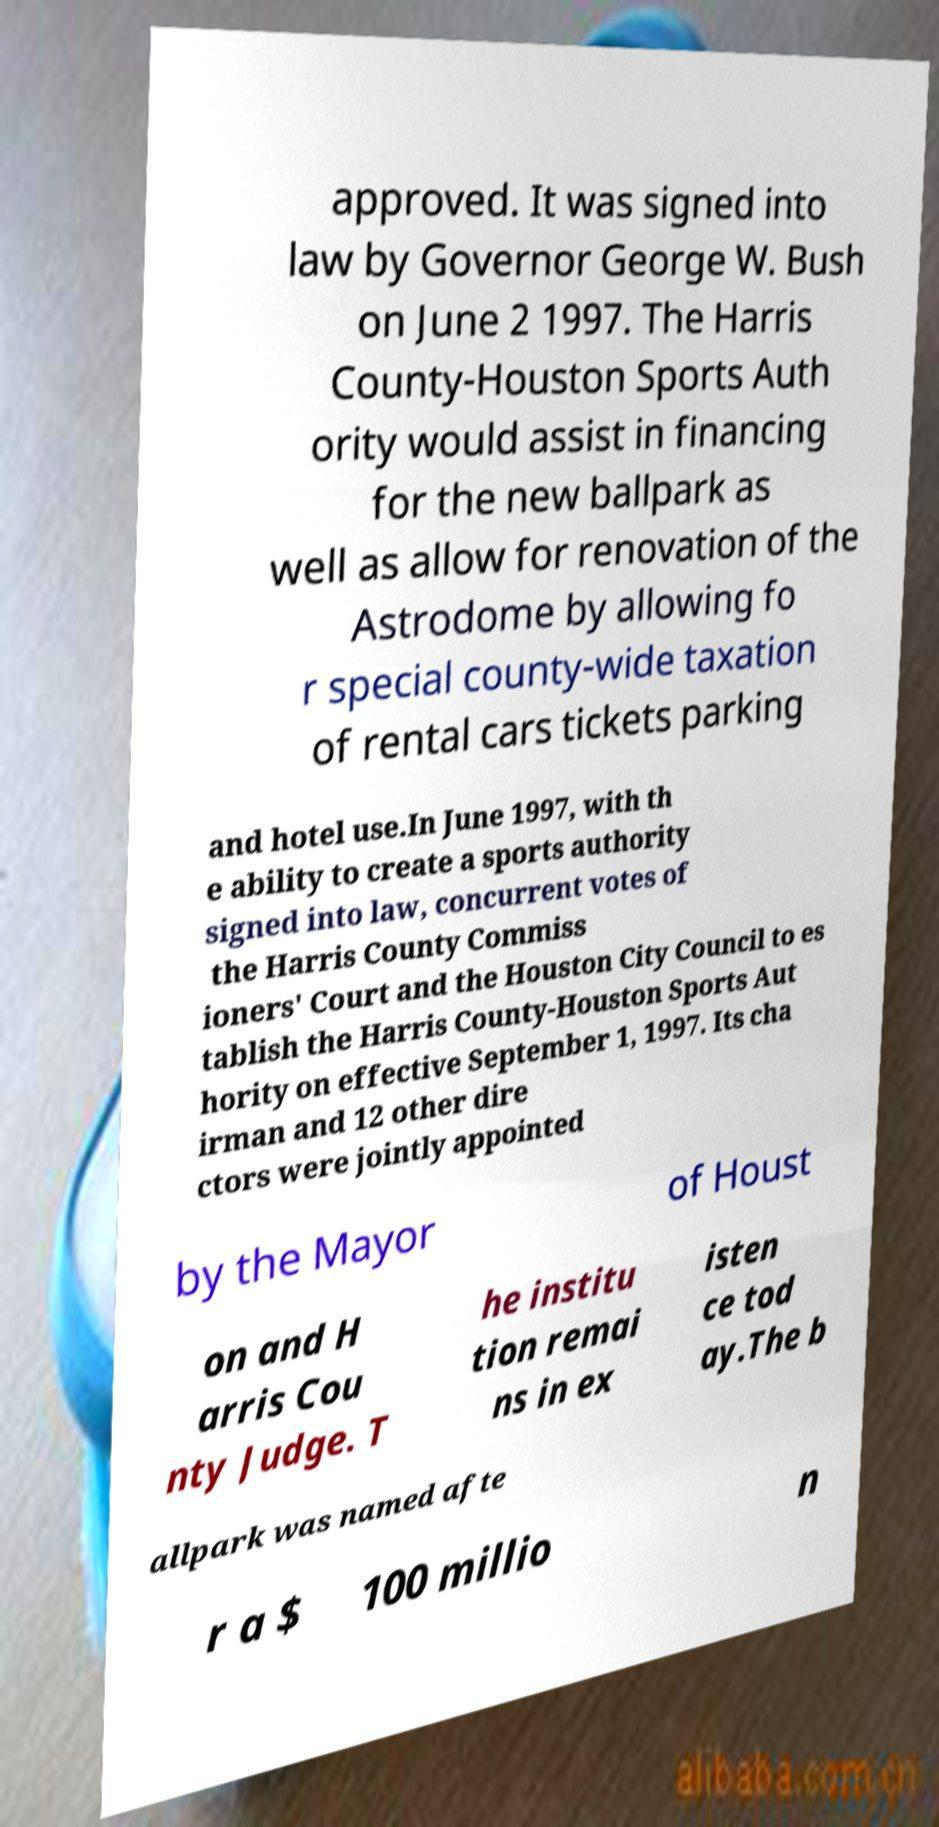Please identify and transcribe the text found in this image. approved. It was signed into law by Governor George W. Bush on June 2 1997. The Harris County-Houston Sports Auth ority would assist in financing for the new ballpark as well as allow for renovation of the Astrodome by allowing fo r special county-wide taxation of rental cars tickets parking and hotel use.In June 1997, with th e ability to create a sports authority signed into law, concurrent votes of the Harris County Commiss ioners' Court and the Houston City Council to es tablish the Harris County-Houston Sports Aut hority on effective September 1, 1997. Its cha irman and 12 other dire ctors were jointly appointed by the Mayor of Houst on and H arris Cou nty Judge. T he institu tion remai ns in ex isten ce tod ay.The b allpark was named afte r a $ 100 millio n 